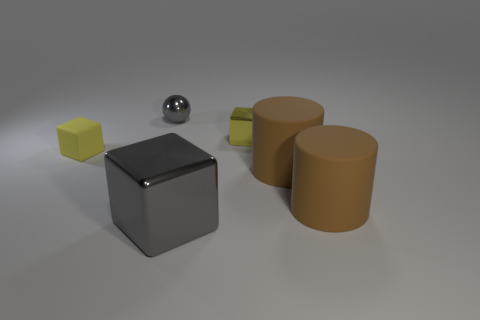Do the small sphere and the big metal block have the same color?
Offer a very short reply. Yes. There is a thing that is the same color as the small metallic block; what is it made of?
Keep it short and to the point. Rubber. Is there a gray cylinder?
Your answer should be very brief. No. There is another tiny yellow thing that is the same shape as the yellow shiny thing; what material is it?
Provide a succinct answer. Rubber. Are there any metal things right of the small gray shiny ball?
Provide a short and direct response. Yes. Does the small yellow block that is left of the tiny yellow shiny object have the same material as the tiny gray object?
Provide a short and direct response. No. Is there a big object of the same color as the small sphere?
Provide a short and direct response. Yes. There is a small gray metal thing; what shape is it?
Give a very brief answer. Sphere. What color is the metal block that is to the left of the small yellow thing that is on the right side of the rubber block?
Your answer should be compact. Gray. What size is the gray shiny object that is in front of the yellow shiny object?
Your answer should be compact. Large. 